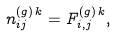Convert formula to latex. <formula><loc_0><loc_0><loc_500><loc_500>n _ { i j } ^ { ( g ) \, k } = F _ { i , j } ^ { ( g ) \, k } ,</formula> 